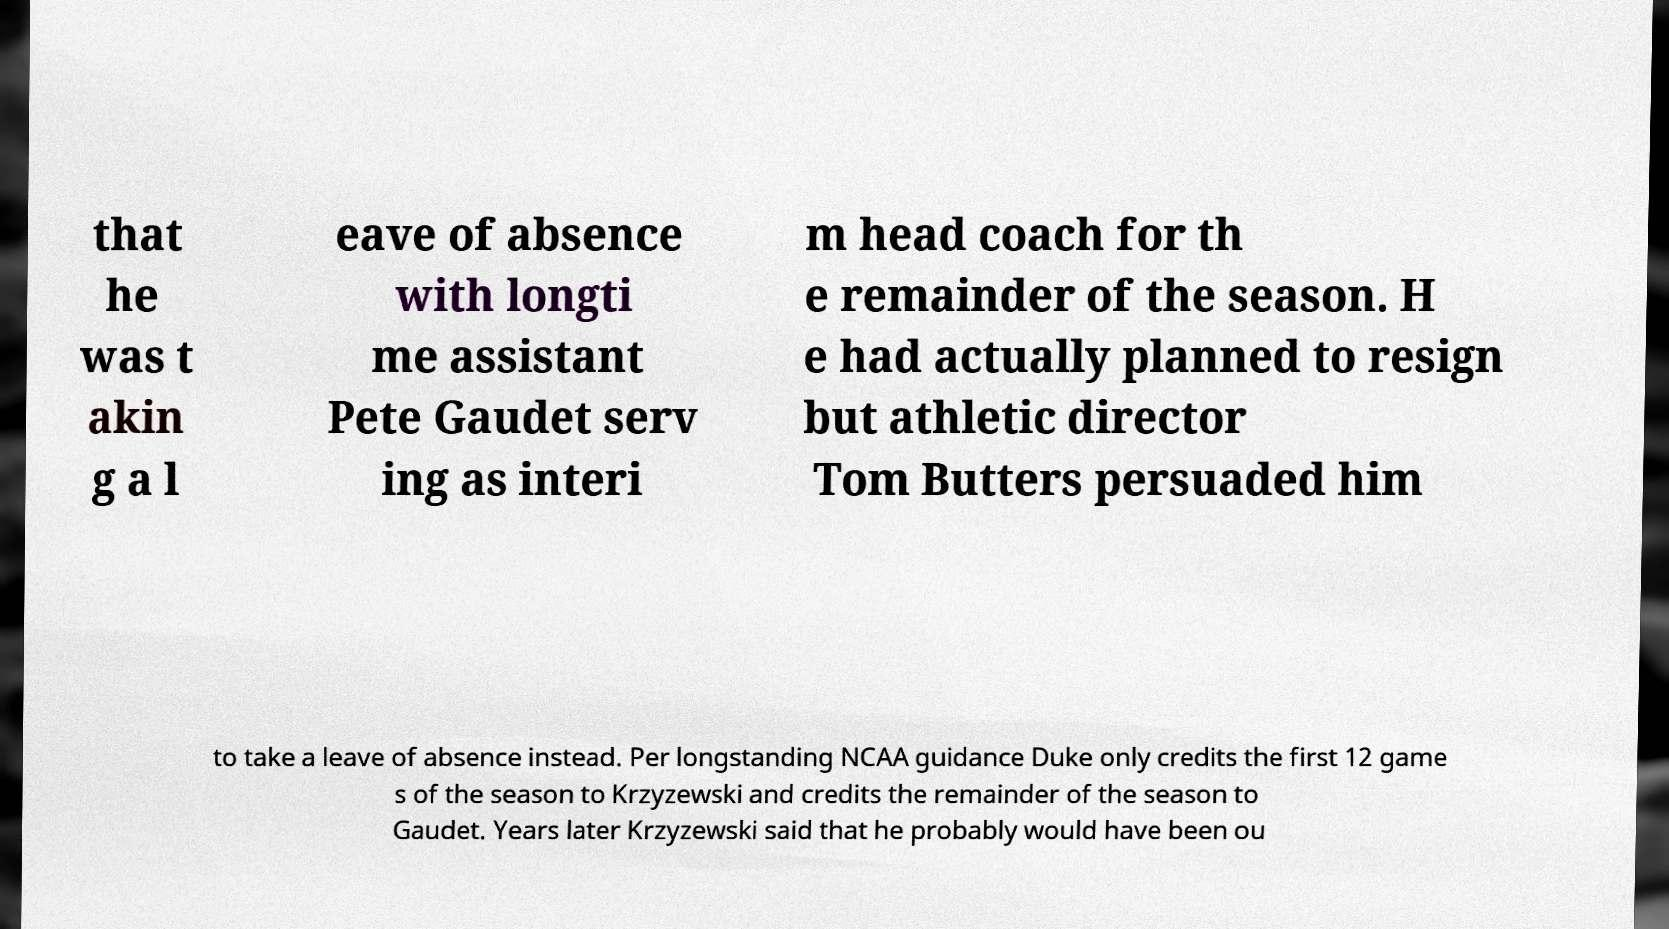Can you accurately transcribe the text from the provided image for me? that he was t akin g a l eave of absence with longti me assistant Pete Gaudet serv ing as interi m head coach for th e remainder of the season. H e had actually planned to resign but athletic director Tom Butters persuaded him to take a leave of absence instead. Per longstanding NCAA guidance Duke only credits the first 12 game s of the season to Krzyzewski and credits the remainder of the season to Gaudet. Years later Krzyzewski said that he probably would have been ou 